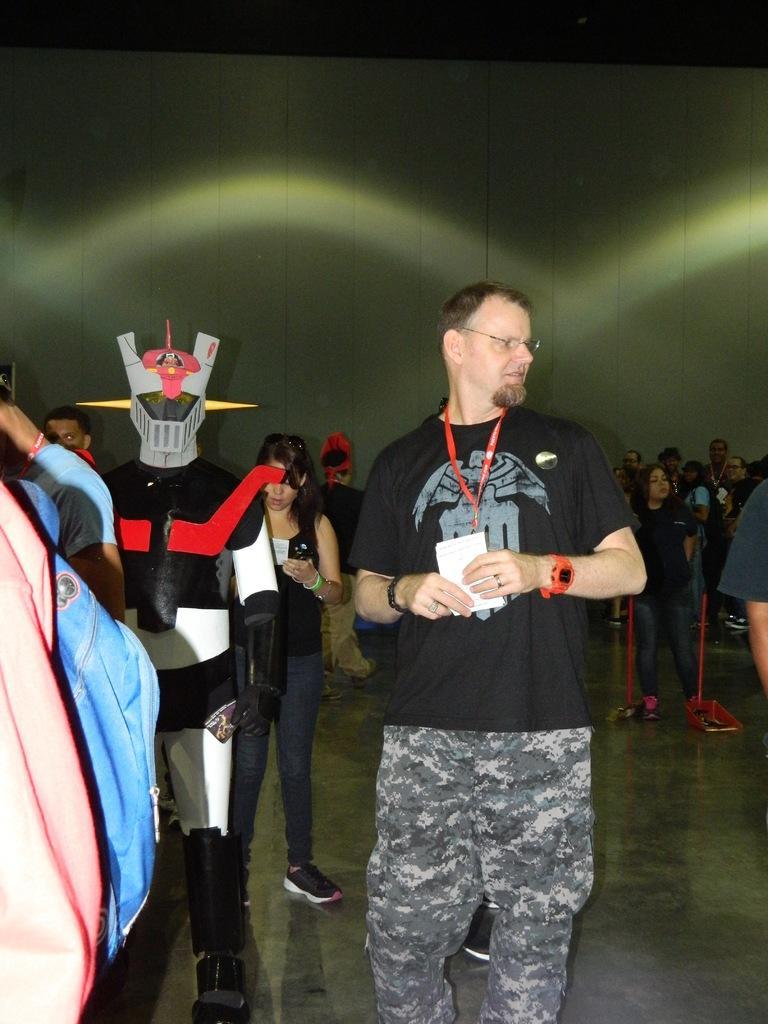Could you give a brief overview of what you see in this image? In this picture we can see some people standing here, at the bottom there is floor, we can see a wall in the background. 